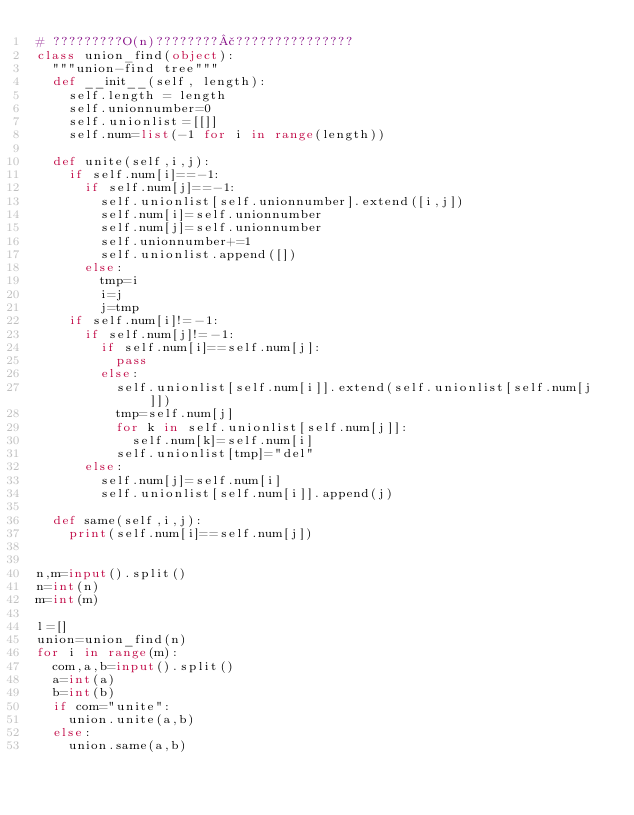Convert code to text. <code><loc_0><loc_0><loc_500><loc_500><_Python_># ?????????O(n)????????£???????????????
class union_find(object):
 	"""union-find tree"""
 	def __init__(self, length):
 		self.length = length
 		self.unionnumber=0
 		self.unionlist=[[]]
 		self.num=list(-1 for i in range(length))

 	def unite(self,i,j):
 		if self.num[i]==-1:
 			if self.num[j]==-1:
 				self.unionlist[self.unionnumber].extend([i,j])
 				self.num[i]=self.unionnumber
 				self.num[j]=self.unionnumber
 				self.unionnumber+=1
 				self.unionlist.append([])
 			else:
 				tmp=i 
 				i=j 
 				j=tmp 
 		if self.num[i]!=-1:
 			if self.num[j]!=-1:
 				if self.num[i]==self.num[j]:
 					pass
 				else:
 					self.unionlist[self.num[i]].extend(self.unionlist[self.num[j]])
 					tmp=self.num[j]
 					for k in self.unionlist[self.num[j]]:
 						self.num[k]=self.num[i]
 					self.unionlist[tmp]="del"
 			else:
 				self.num[j]=self.num[i]
 				self.unionlist[self.num[i]].append(j)

 	def same(self,i,j):
 		print(self.num[i]==self.num[j])


n,m=input().split()
n=int(n)
m=int(m)

l=[]
union=union_find(n)
for i in range(m):
	com,a,b=input().split()
	a=int(a)
	b=int(b)
	if com="unite":
		union.unite(a,b)
	else:
		union.same(a,b)</code> 